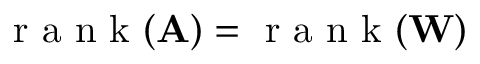Convert formula to latex. <formula><loc_0><loc_0><loc_500><loc_500>r a n k ( A ) = r a n k ( W )</formula> 